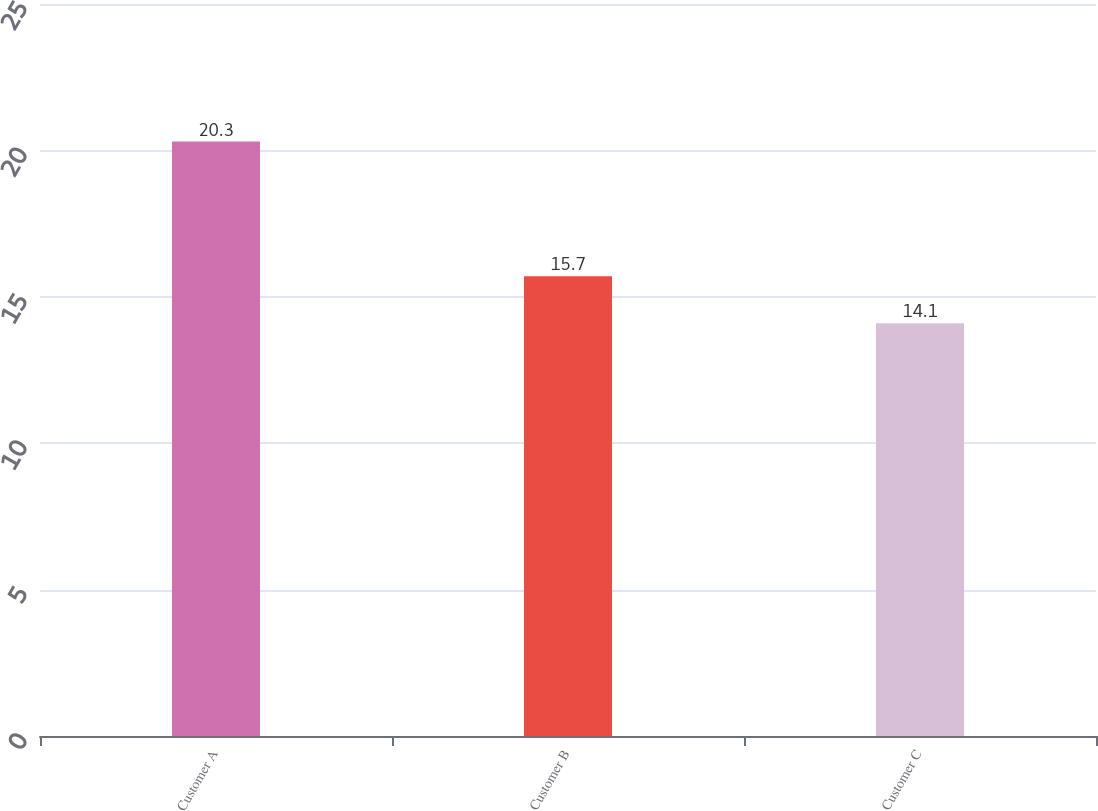Convert chart to OTSL. <chart><loc_0><loc_0><loc_500><loc_500><bar_chart><fcel>Customer A<fcel>Customer B<fcel>Customer C<nl><fcel>20.3<fcel>15.7<fcel>14.1<nl></chart> 